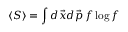<formula> <loc_0><loc_0><loc_500><loc_500>\langle S \rangle = \int d \vec { x } d \vec { p } \, f \log f</formula> 